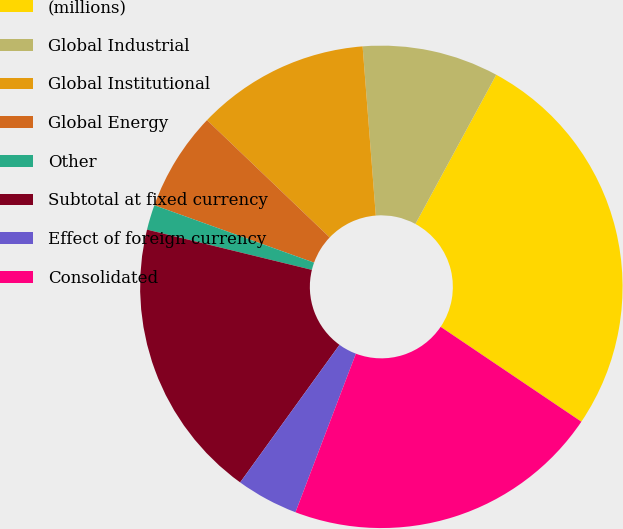Convert chart to OTSL. <chart><loc_0><loc_0><loc_500><loc_500><pie_chart><fcel>(millions)<fcel>Global Industrial<fcel>Global Institutional<fcel>Global Energy<fcel>Other<fcel>Subtotal at fixed currency<fcel>Effect of foreign currency<fcel>Consolidated<nl><fcel>26.54%<fcel>9.14%<fcel>11.62%<fcel>6.65%<fcel>1.68%<fcel>18.86%<fcel>4.16%<fcel>21.35%<nl></chart> 